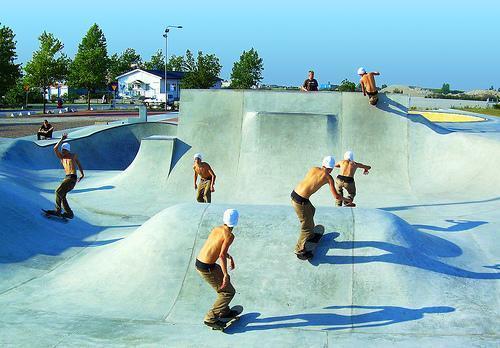How many skateboarders are performing tricks?
Give a very brief answer. 6. How many light posts are there?
Give a very brief answer. 1. 